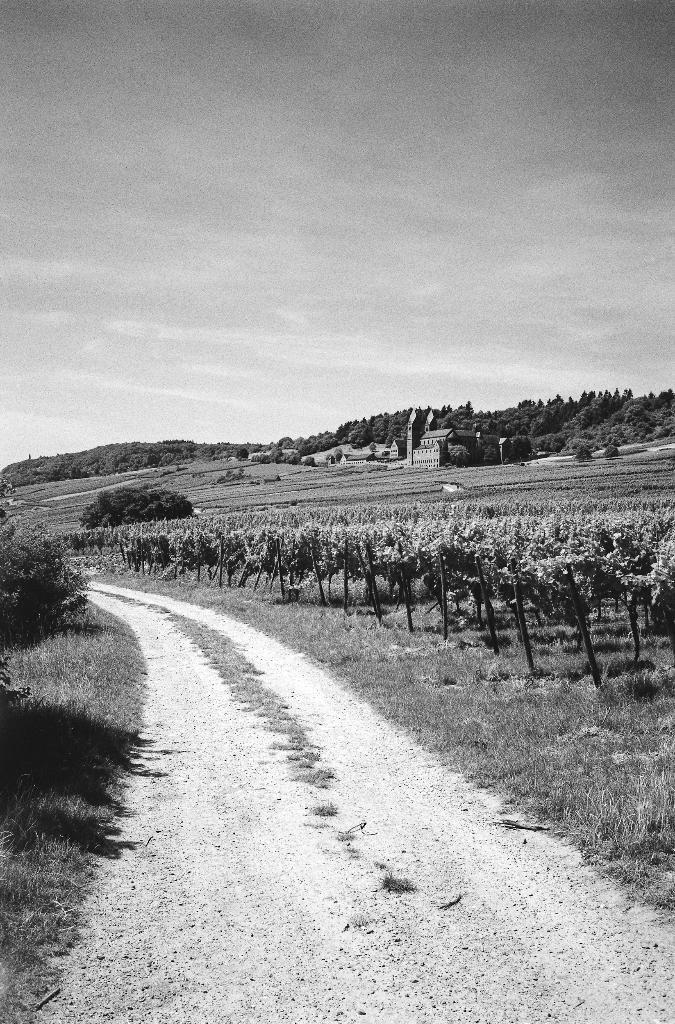How would you summarize this image in a sentence or two? In the picture I can see the road, beside the road there are some trees, grass and some buildings. 